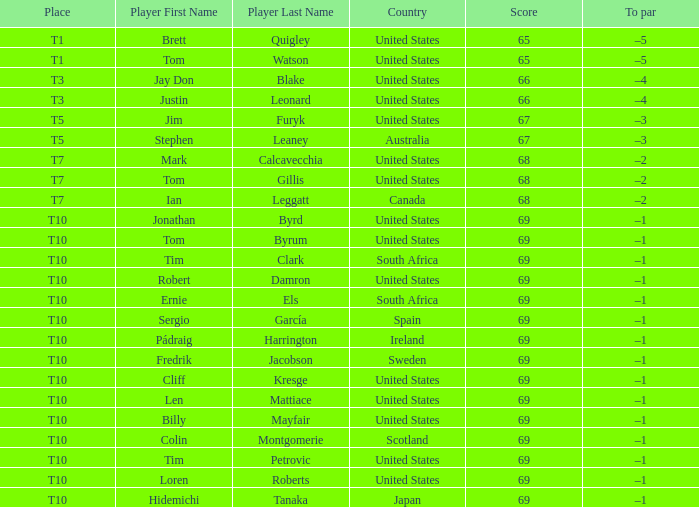What is Tom Gillis' score? 68.0. 